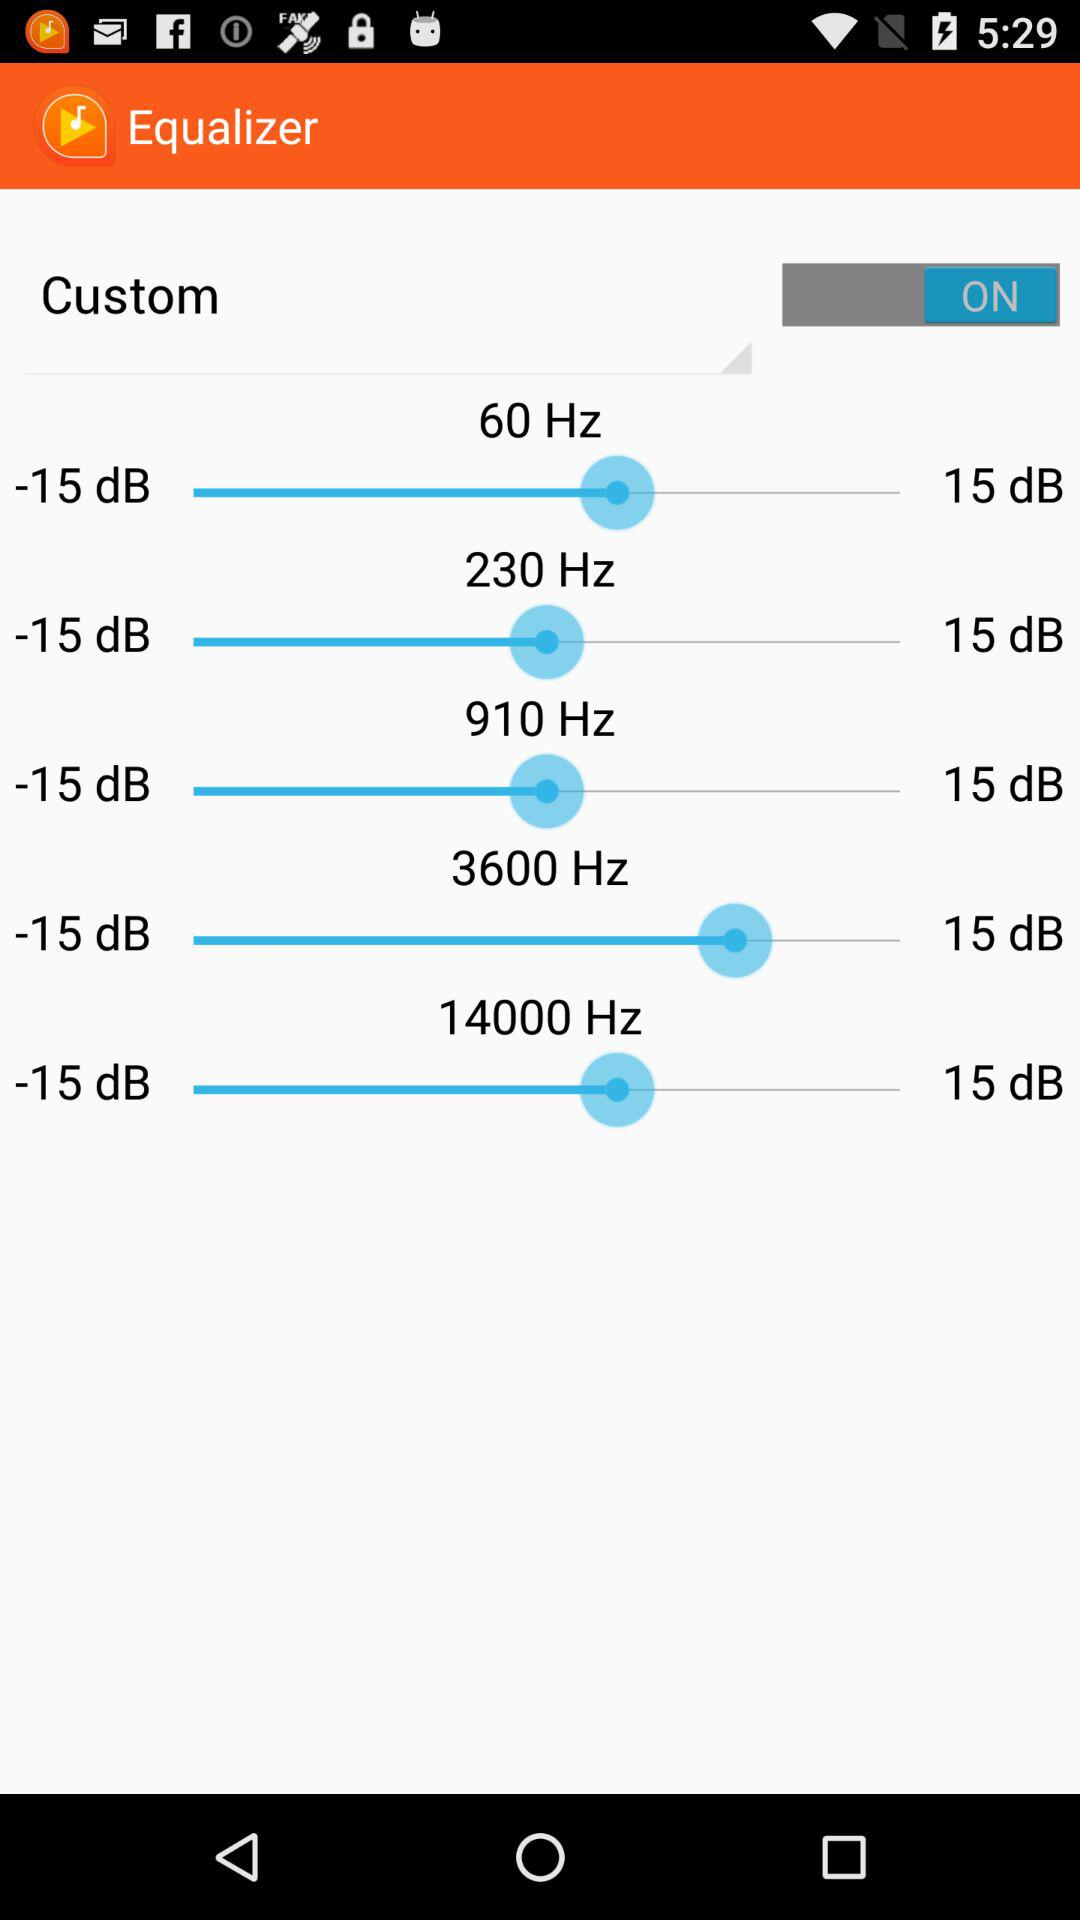What is the noise range for the 60 Hz frequency? The noise range for the 60 Hz frequency is from -15 dB to 15 dB. 